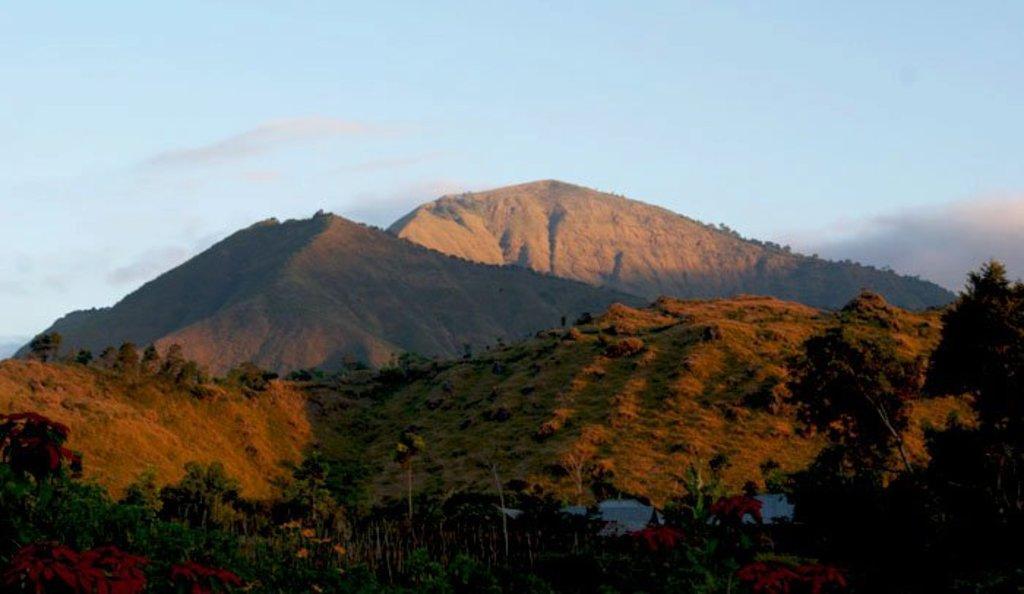Please provide a concise description of this image. In this image I can see trees in green color, background I can see mountains and the sky is in blue and white color. 